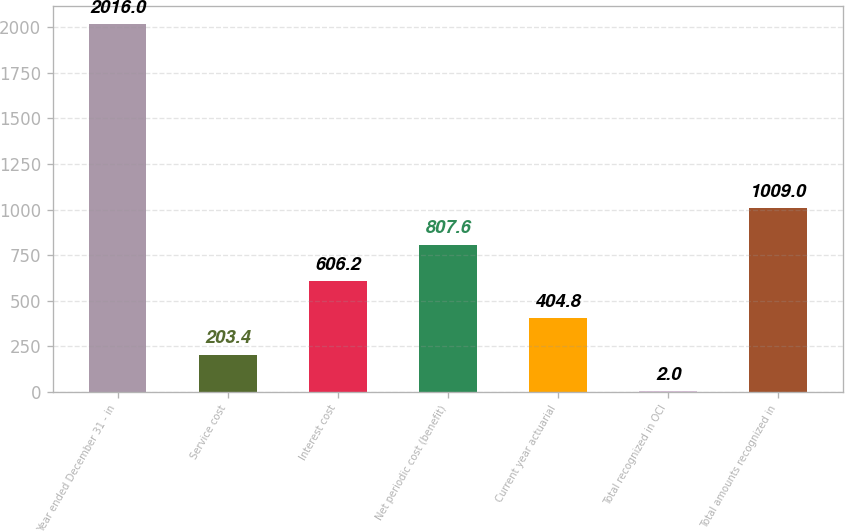Convert chart to OTSL. <chart><loc_0><loc_0><loc_500><loc_500><bar_chart><fcel>Year ended December 31 - in<fcel>Service cost<fcel>Interest cost<fcel>Net periodic cost (benefit)<fcel>Current year actuarial<fcel>Total recognized in OCI<fcel>Total amounts recognized in<nl><fcel>2016<fcel>203.4<fcel>606.2<fcel>807.6<fcel>404.8<fcel>2<fcel>1009<nl></chart> 